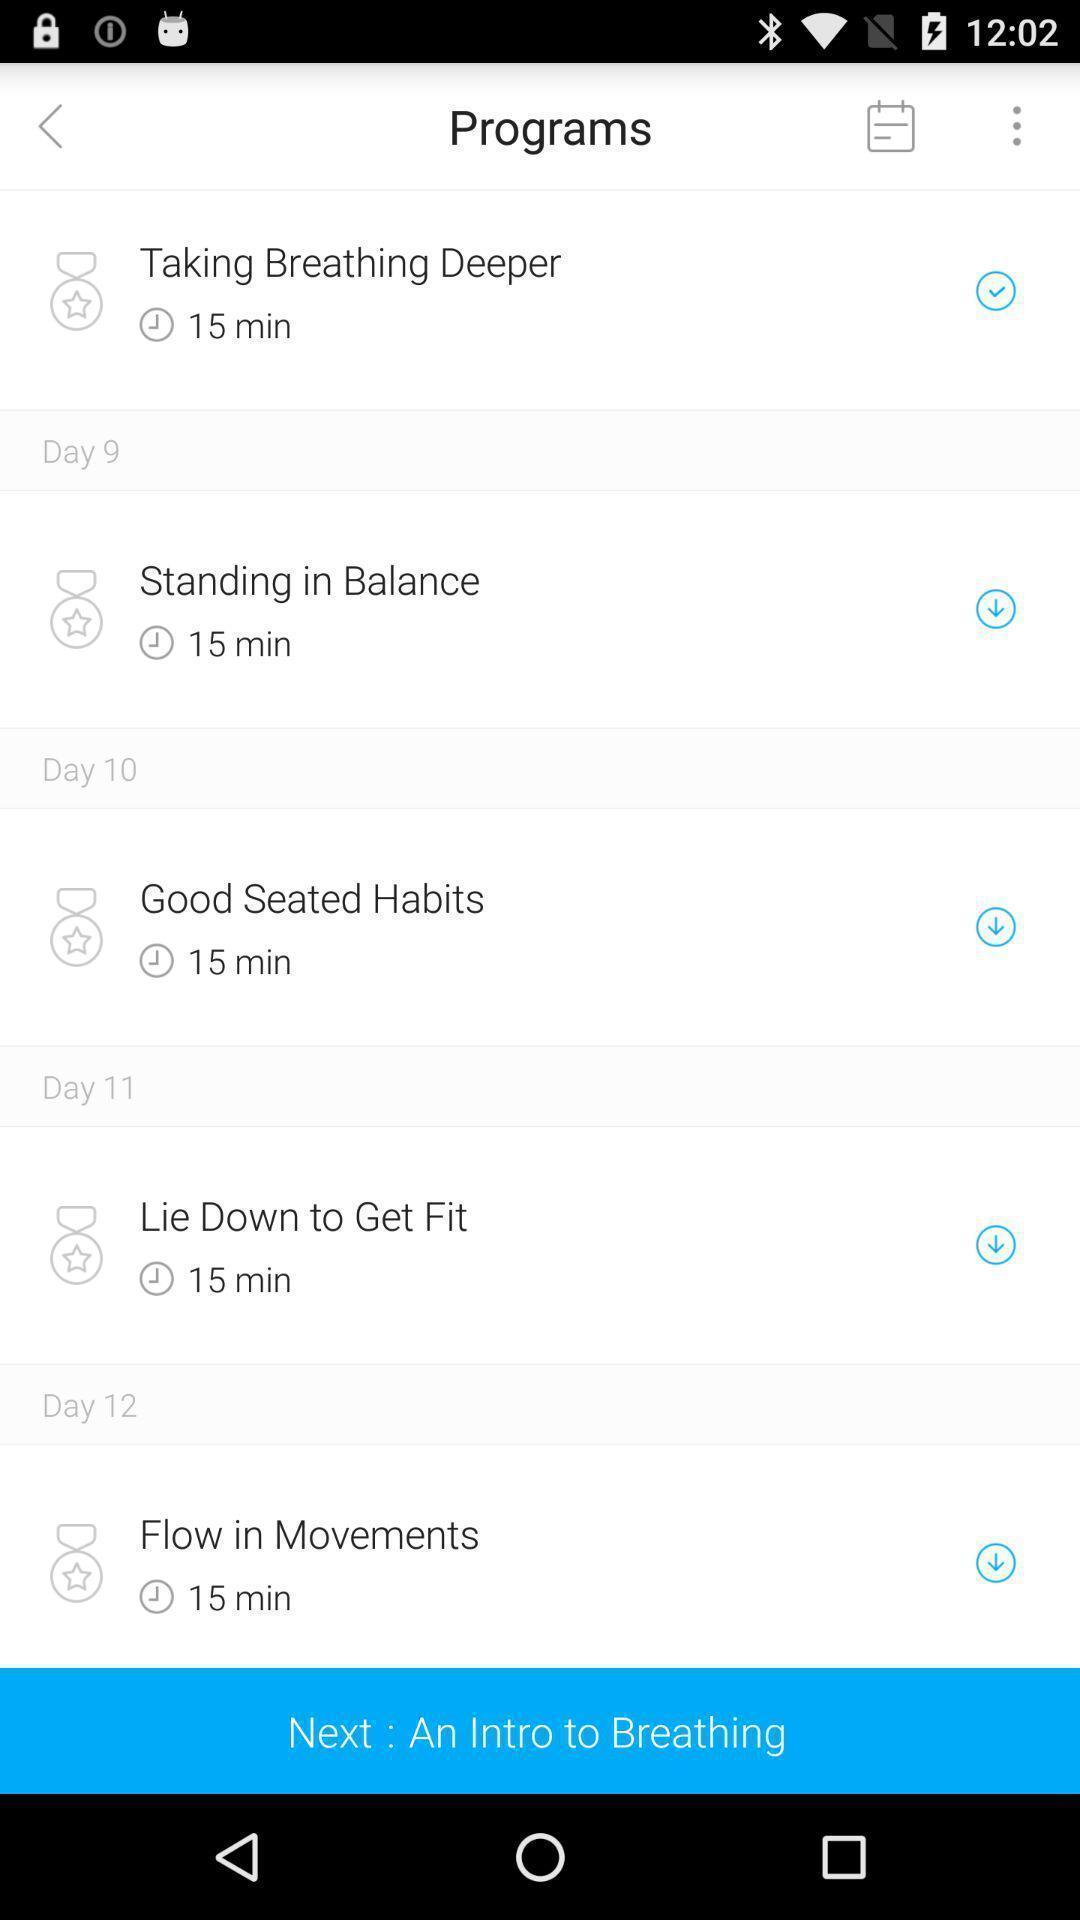Describe this image in words. Screen displaying a list of program names with time duration. 